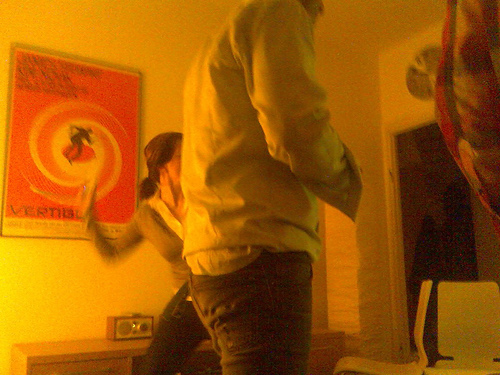Is there any indication of the time period this photo was taken? The specific time period is difficult to determine, but the style of the clothes worn by the individuals and the design of the poster suggest a contemporary setting. Describe the lighting mood in the room. The room has a warm and inviting ambiance, created by what seems to be soft, yellow-hued lighting, which enhances the impression of a private and comfortable space. 